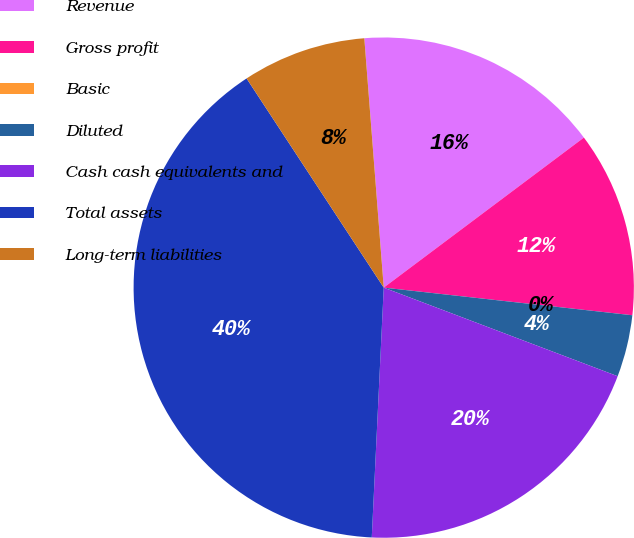Convert chart. <chart><loc_0><loc_0><loc_500><loc_500><pie_chart><fcel>Revenue<fcel>Gross profit<fcel>Basic<fcel>Diluted<fcel>Cash cash equivalents and<fcel>Total assets<fcel>Long-term liabilities<nl><fcel>16.0%<fcel>12.0%<fcel>0.0%<fcel>4.0%<fcel>20.0%<fcel>40.0%<fcel>8.0%<nl></chart> 